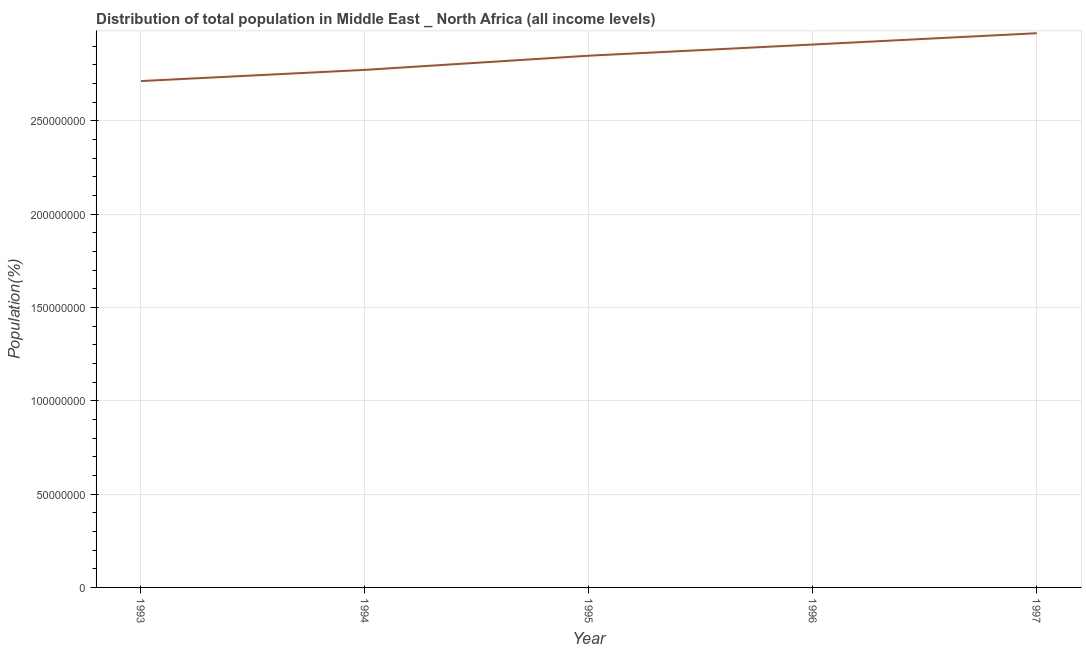What is the population in 1995?
Ensure brevity in your answer.  2.85e+08. Across all years, what is the maximum population?
Keep it short and to the point. 2.97e+08. Across all years, what is the minimum population?
Provide a succinct answer. 2.71e+08. In which year was the population maximum?
Offer a very short reply. 1997. In which year was the population minimum?
Provide a succinct answer. 1993. What is the sum of the population?
Make the answer very short. 1.42e+09. What is the difference between the population in 1995 and 1996?
Your answer should be very brief. -5.98e+06. What is the average population per year?
Provide a succinct answer. 2.84e+08. What is the median population?
Make the answer very short. 2.85e+08. Do a majority of the years between 1993 and 1997 (inclusive) have population greater than 50000000 %?
Ensure brevity in your answer.  Yes. What is the ratio of the population in 1993 to that in 1997?
Your response must be concise. 0.91. Is the population in 1994 less than that in 1997?
Ensure brevity in your answer.  Yes. What is the difference between the highest and the second highest population?
Give a very brief answer. 6.06e+06. Is the sum of the population in 1993 and 1995 greater than the maximum population across all years?
Your answer should be compact. Yes. What is the difference between the highest and the lowest population?
Keep it short and to the point. 2.56e+07. Does the population monotonically increase over the years?
Keep it short and to the point. Yes. How many lines are there?
Give a very brief answer. 1. What is the difference between two consecutive major ticks on the Y-axis?
Keep it short and to the point. 5.00e+07. What is the title of the graph?
Give a very brief answer. Distribution of total population in Middle East _ North Africa (all income levels) . What is the label or title of the X-axis?
Your answer should be compact. Year. What is the label or title of the Y-axis?
Your answer should be compact. Population(%). What is the Population(%) of 1993?
Make the answer very short. 2.71e+08. What is the Population(%) of 1994?
Provide a short and direct response. 2.77e+08. What is the Population(%) in 1995?
Offer a terse response. 2.85e+08. What is the Population(%) of 1996?
Ensure brevity in your answer.  2.91e+08. What is the Population(%) of 1997?
Your answer should be very brief. 2.97e+08. What is the difference between the Population(%) in 1993 and 1994?
Provide a succinct answer. -5.99e+06. What is the difference between the Population(%) in 1993 and 1995?
Provide a succinct answer. -1.36e+07. What is the difference between the Population(%) in 1993 and 1996?
Your answer should be compact. -1.96e+07. What is the difference between the Population(%) in 1993 and 1997?
Offer a very short reply. -2.56e+07. What is the difference between the Population(%) in 1994 and 1995?
Ensure brevity in your answer.  -7.60e+06. What is the difference between the Population(%) in 1994 and 1996?
Give a very brief answer. -1.36e+07. What is the difference between the Population(%) in 1994 and 1997?
Provide a short and direct response. -1.96e+07. What is the difference between the Population(%) in 1995 and 1996?
Provide a short and direct response. -5.98e+06. What is the difference between the Population(%) in 1995 and 1997?
Ensure brevity in your answer.  -1.20e+07. What is the difference between the Population(%) in 1996 and 1997?
Provide a short and direct response. -6.06e+06. What is the ratio of the Population(%) in 1993 to that in 1996?
Give a very brief answer. 0.93. What is the ratio of the Population(%) in 1993 to that in 1997?
Give a very brief answer. 0.91. What is the ratio of the Population(%) in 1994 to that in 1995?
Your answer should be very brief. 0.97. What is the ratio of the Population(%) in 1994 to that in 1996?
Offer a very short reply. 0.95. What is the ratio of the Population(%) in 1994 to that in 1997?
Provide a succinct answer. 0.93. 